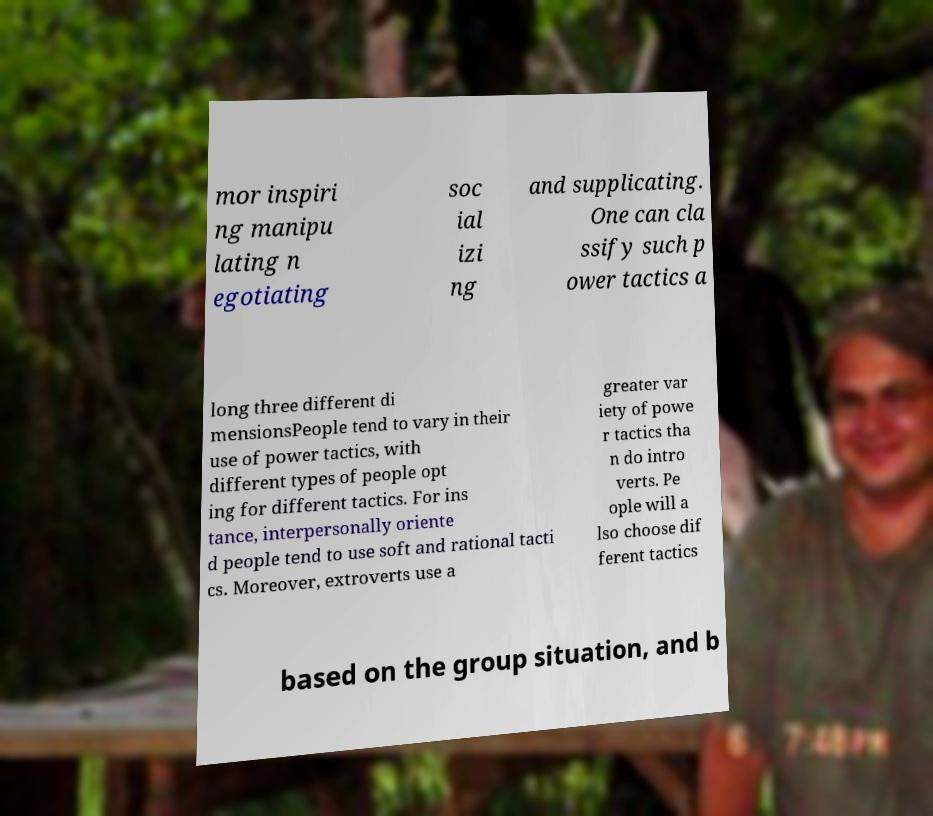Can you read and provide the text displayed in the image?This photo seems to have some interesting text. Can you extract and type it out for me? mor inspiri ng manipu lating n egotiating soc ial izi ng and supplicating. One can cla ssify such p ower tactics a long three different di mensionsPeople tend to vary in their use of power tactics, with different types of people opt ing for different tactics. For ins tance, interpersonally oriente d people tend to use soft and rational tacti cs. Moreover, extroverts use a greater var iety of powe r tactics tha n do intro verts. Pe ople will a lso choose dif ferent tactics based on the group situation, and b 